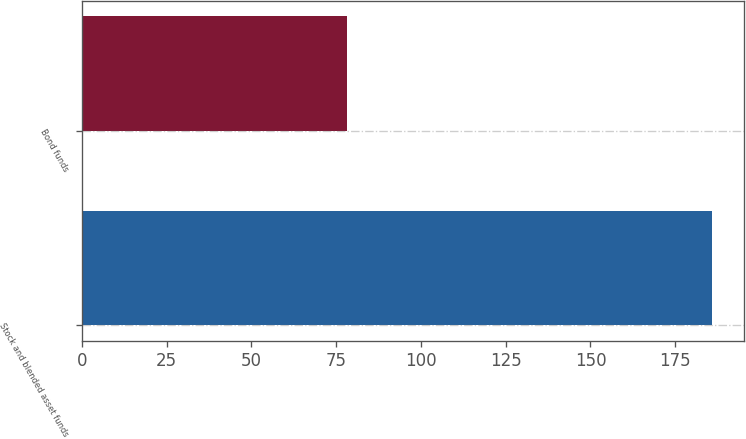Convert chart to OTSL. <chart><loc_0><loc_0><loc_500><loc_500><bar_chart><fcel>Stock and blended asset funds<fcel>Bond funds<nl><fcel>185.9<fcel>78.3<nl></chart> 